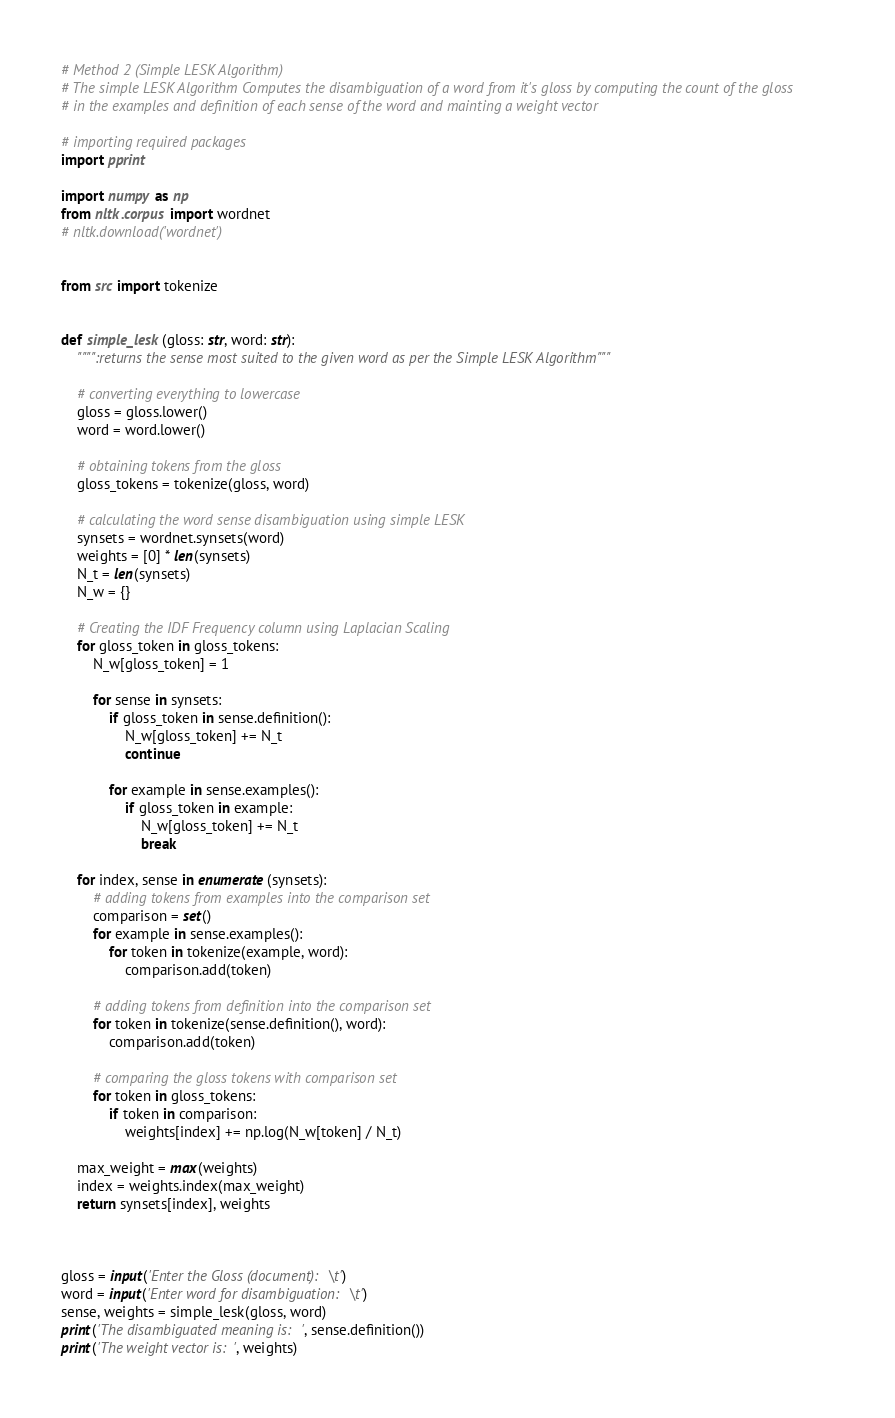Convert code to text. <code><loc_0><loc_0><loc_500><loc_500><_Python_># Method 2 (Simple LESK Algorithm)
# The simple LESK Algorithm Computes the disambiguation of a word from it's gloss by computing the count of the gloss
# in the examples and definition of each sense of the word and mainting a weight vector

# importing required packages
import pprint

import numpy as np
from nltk.corpus import wordnet
# nltk.download('wordnet')


from src import tokenize


def simple_lesk(gloss: str, word: str):
    """":returns the sense most suited to the given word as per the Simple LESK Algorithm"""

    # converting everything to lowercase
    gloss = gloss.lower()
    word = word.lower()

    # obtaining tokens from the gloss
    gloss_tokens = tokenize(gloss, word)

    # calculating the word sense disambiguation using simple LESK
    synsets = wordnet.synsets(word)
    weights = [0] * len(synsets)
    N_t = len(synsets)
    N_w = {}

    # Creating the IDF Frequency column using Laplacian Scaling
    for gloss_token in gloss_tokens:
        N_w[gloss_token] = 1

        for sense in synsets:
            if gloss_token in sense.definition():
                N_w[gloss_token] += N_t
                continue

            for example in sense.examples():
                if gloss_token in example:
                    N_w[gloss_token] += N_t
                    break

    for index, sense in enumerate(synsets):
        # adding tokens from examples into the comparison set
        comparison = set()
        for example in sense.examples():
            for token in tokenize(example, word):
                comparison.add(token)

        # adding tokens from definition into the comparison set
        for token in tokenize(sense.definition(), word):
            comparison.add(token)

        # comparing the gloss tokens with comparison set
        for token in gloss_tokens:
            if token in comparison:
                weights[index] += np.log(N_w[token] / N_t)

    max_weight = max(weights)
    index = weights.index(max_weight)
    return synsets[index], weights



gloss = input('Enter the Gloss (document):\t')
word = input('Enter word for disambiguation:\t')
sense, weights = simple_lesk(gloss, word)
print('The disambiguated meaning is:', sense.definition())
print('The weight vector is:', weights)
</code> 